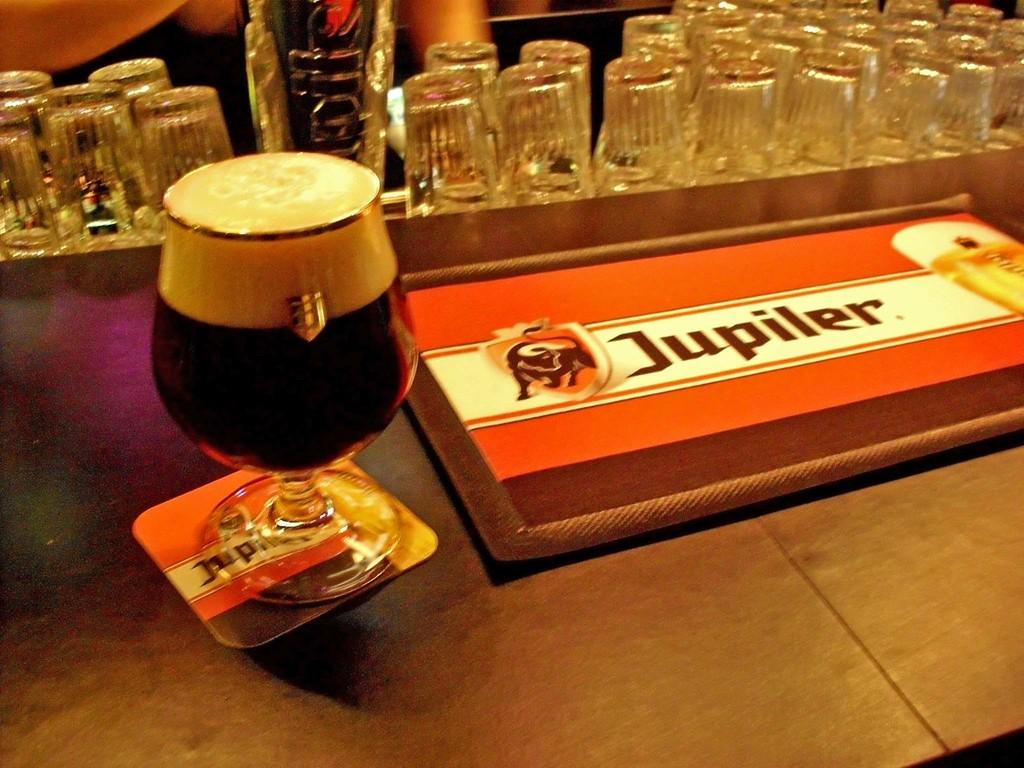<image>
Offer a succinct explanation of the picture presented. a jupiter bar sitting on the table with beer 